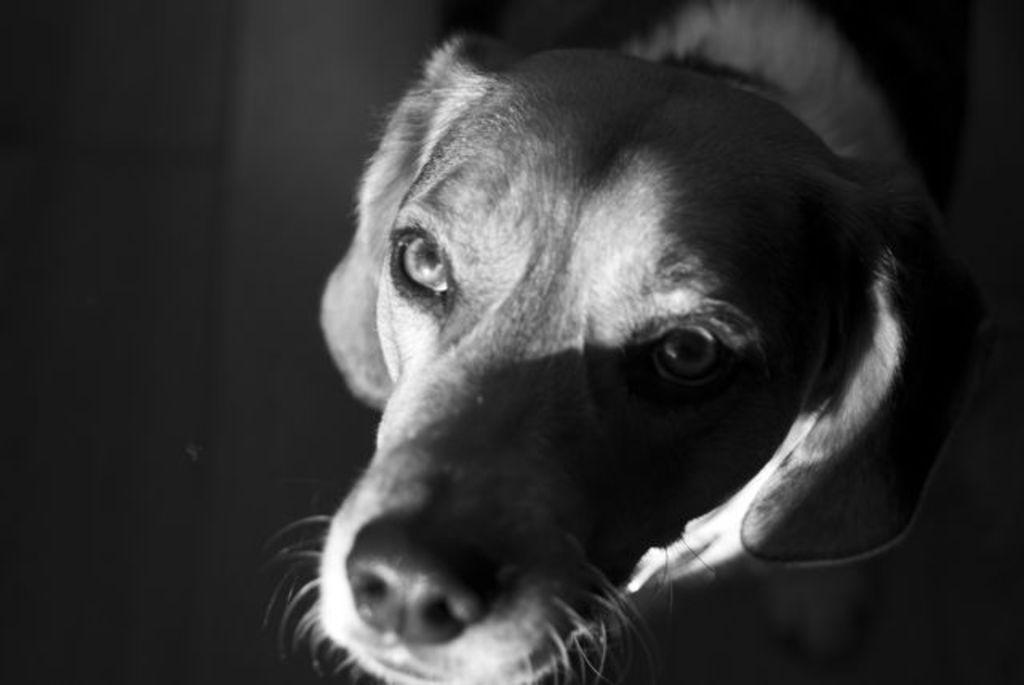Please provide a concise description of this image. In this image I can see a dog and the image is in black and white. 